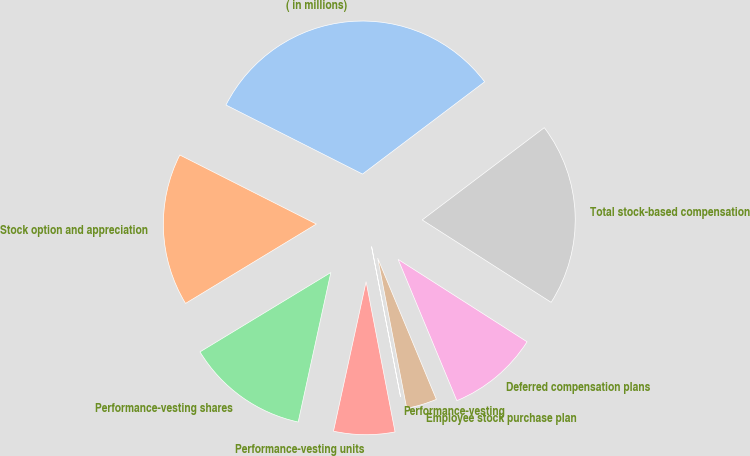Convert chart. <chart><loc_0><loc_0><loc_500><loc_500><pie_chart><fcel>( in millions)<fcel>Stock option and appreciation<fcel>Performance-vesting shares<fcel>Performance-vesting units<fcel>Performance-vesting<fcel>Employee stock purchase plan<fcel>Deferred compensation plans<fcel>Total stock-based compensation<nl><fcel>32.25%<fcel>16.13%<fcel>12.9%<fcel>6.45%<fcel>0.01%<fcel>3.23%<fcel>9.68%<fcel>19.35%<nl></chart> 